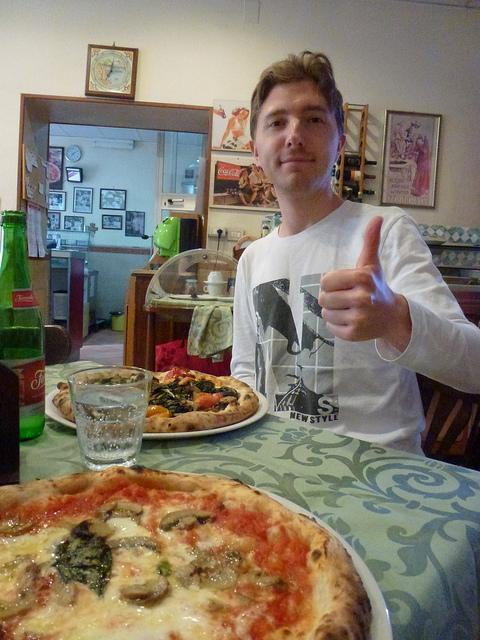Why is the man giving a thumbs up to the viewer? Please explain your reasoning. showing approval. The man likes his food. 